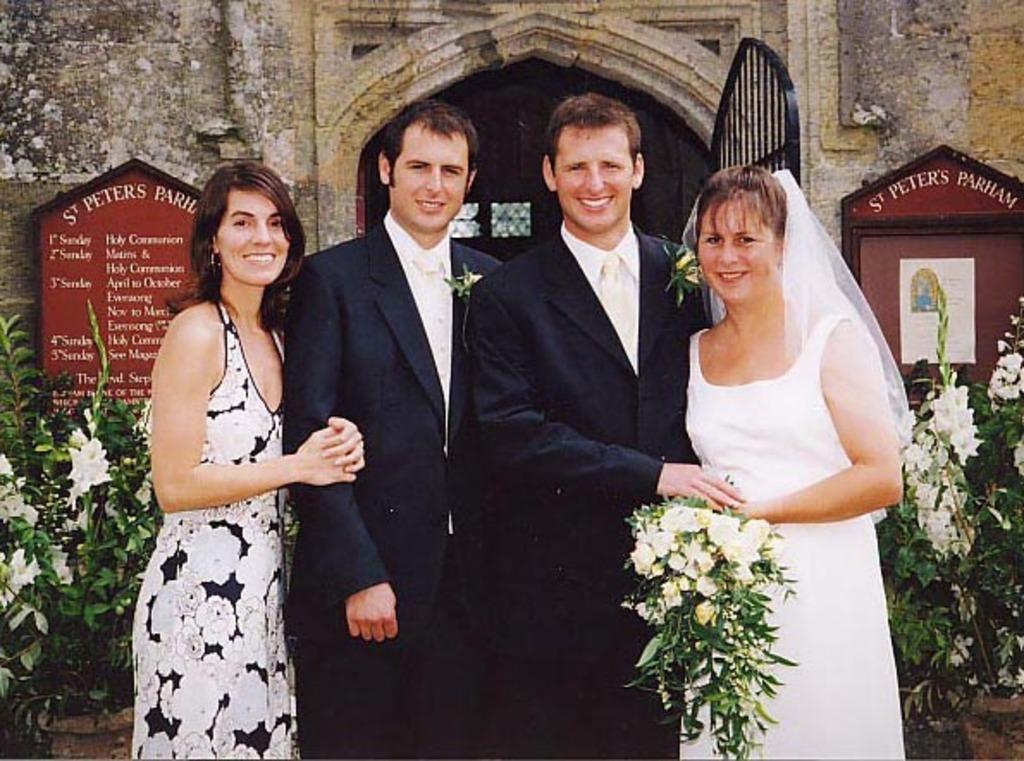How would you summarize this image in a sentence or two? Here in this picture in the middle we can see two men standing over there and on the either side of them we can see woman standing and we can see all of them are smiling and we can see the woman on the right side is holding a flower bouquet in her hand and behind them we can see flower plants present all over there and we can see a gate present and we can see some boards present on the wall over there. 